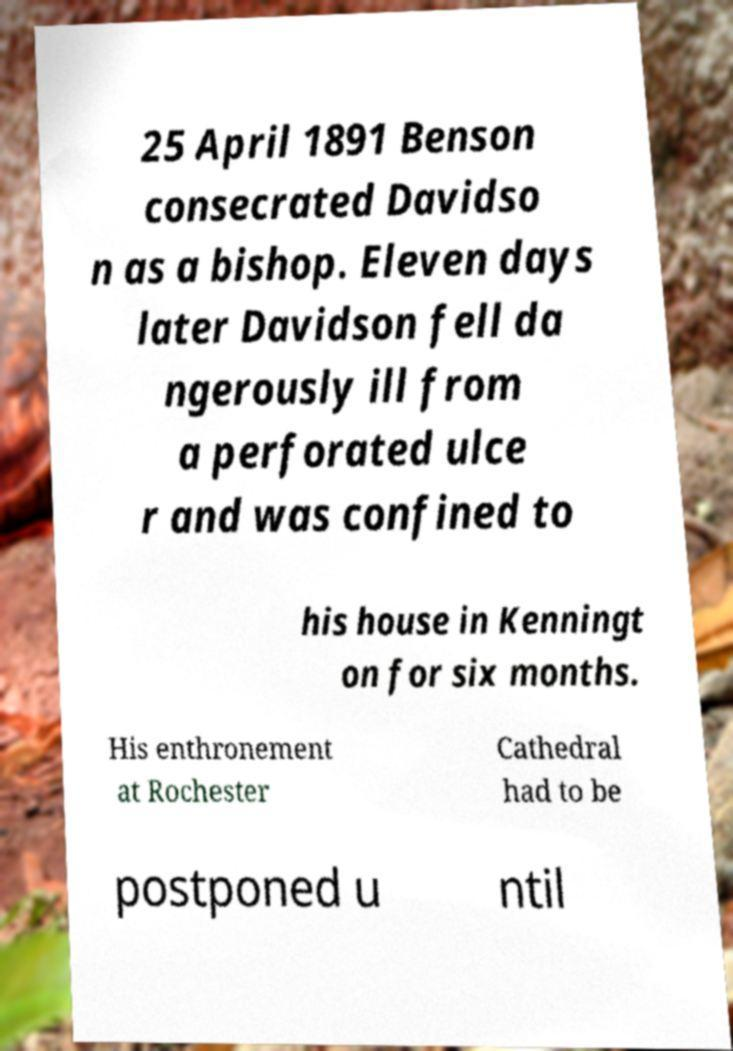For documentation purposes, I need the text within this image transcribed. Could you provide that? 25 April 1891 Benson consecrated Davidso n as a bishop. Eleven days later Davidson fell da ngerously ill from a perforated ulce r and was confined to his house in Kenningt on for six months. His enthronement at Rochester Cathedral had to be postponed u ntil 